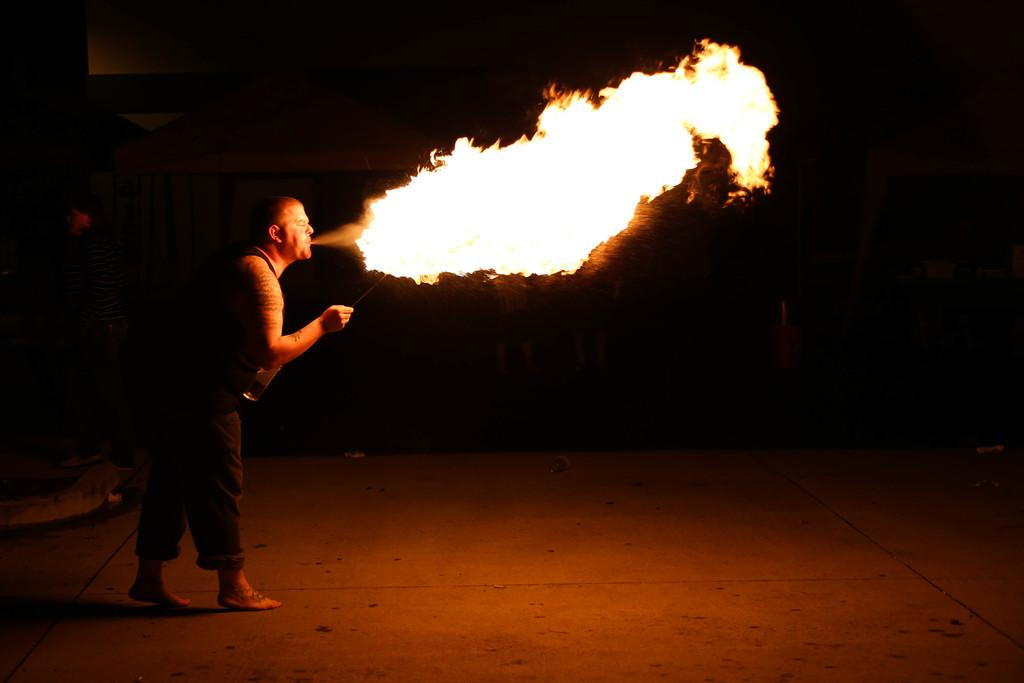What is the main subject of the image? There is a man standing in the image. Where is the man standing? The man is standing on the ground. What can be seen in the image besides the man? There is fire visible in the image. How would you describe the lighting in the image? The image appears to be dark. What type of horse is wearing a stocking in the image? There is no horse or stocking present in the image; it features a man standing on the ground with fire visible. How does the man say good-bye to the fire in the image? The image does not show any interaction between the man and the fire, nor does it depict the man saying good-bye. 